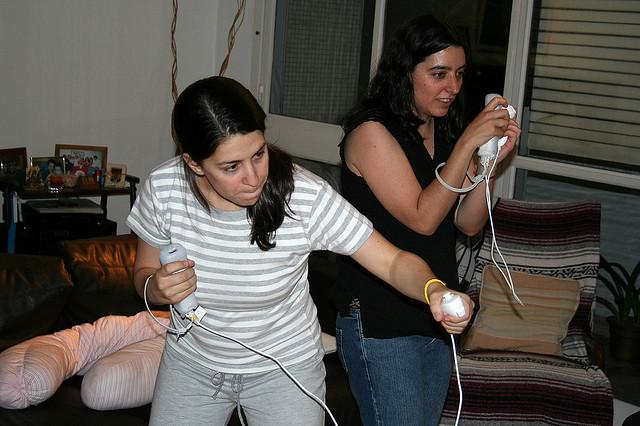What is probably in front of them? Please explain your reasoning. video game. The girls are playing with consoles. 